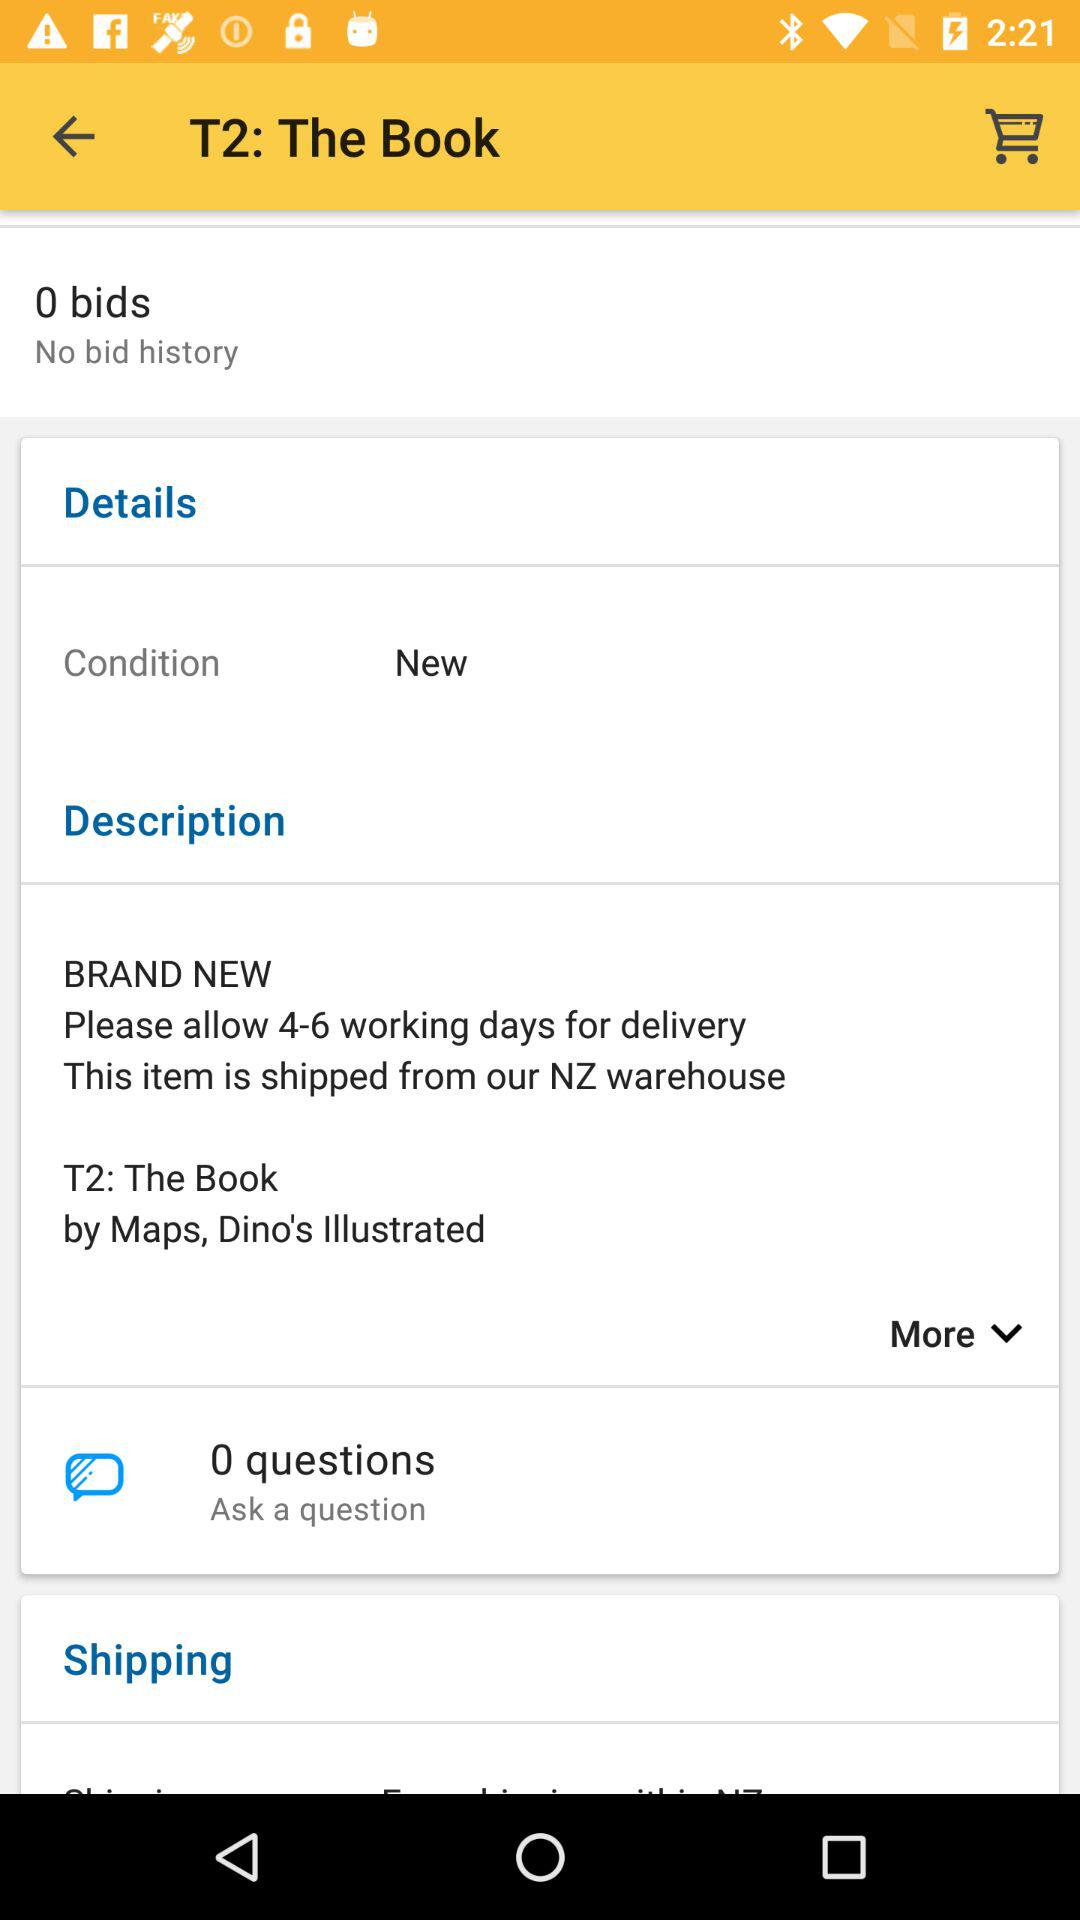What are the two options in the "Details" setting? The two options are "Condition" and "New". 